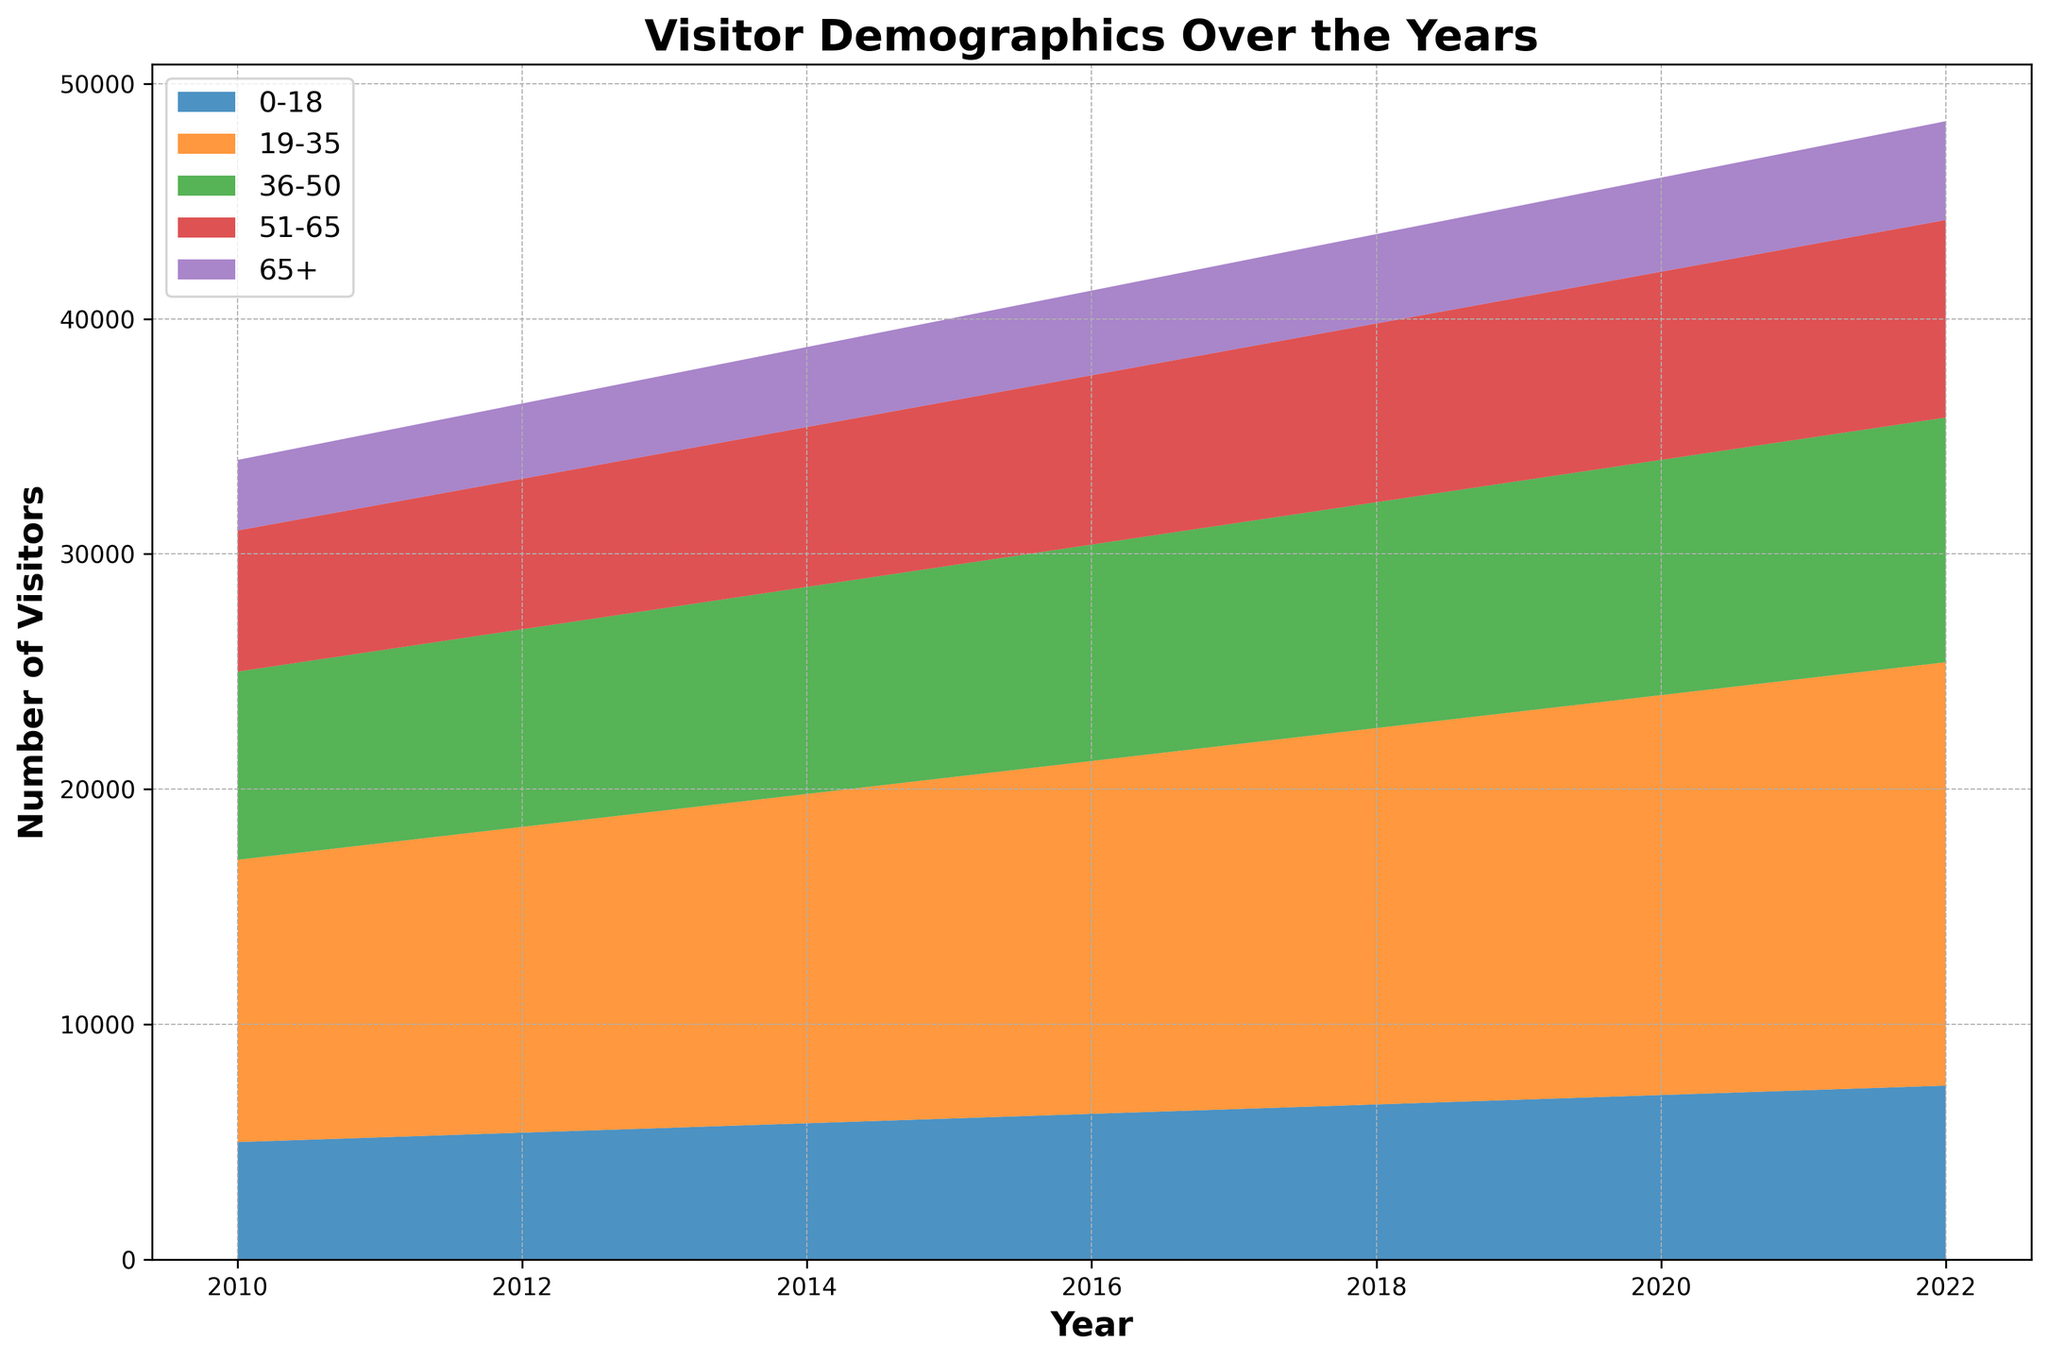What is the total number of visitors for the year 2015? Sum the numbers for each age group in 2015: 6000 (0-18) + 14500 (19-35) + 9000 (36-50) + 7000 (51-65) + 3500 (65+).
Answer: 40,000 Which age group showed the most significant growth in visitors from 2010 to 2022? Subtract the number of visitors in 2010 from the number in 2022 for each age group and find the maximum difference. (19-35) group: 18000 - 12000 = 6000; (0-18) group: 7400 - 5000 = 2400; (36-50) group: 10400 - 8000 = 2400; (51-65) group: 8400 - 6000 = 2400; (65+) group: 4200 - 3000 = 1200.
Answer: 19-35 group In which year did visitors aged 36-50 exceed 10,000 for the first time? Look at the 36-50 line and find the first year where the visitors in this age group exceed 10,000: that occurs in 2020.
Answer: 2020 Compare the increase in visitors for the age groups 0-18 and 65+ from 2010 to 2022. Which had a larger increase? Calculate the increase for each group: (0-18) group, 7400 - 5000 = 2400 increase; (65+) group, 4200 - 3000 = 1200 increase.
Answer: 0-18 group How many more visitors were there in the 19-35 age group compared to the 51-65 group in 2022? Subtract the number of visitors in 2022 for the 51-65 group from the 19-35 group: 18000 (19-35) - 8400 (51-65) = 9600.
Answer: 9600 Which year showed the least number of visitors for the 65+ age group? Identify the year with the smallest value in the 65+ line: the year 2010 with 3000 visitors.
Answer: 2010 What is the average number of visitors in the 36-50 age group from 2010 to 2022? Sum the 36-50 values from each year and divide by the number of years: (8000 + 8200 + 8400 + 8600 + 8800 + 9000 + 9200 + 9400 + 9600 + 9800 + 10000 + 10200 + 10400) / 13 = 9262.
Answer: 9262 Which age group consistently had the highest number of visitors each year from 2010 to 2022? Look at each year and determine which age group has the highest value; the 19-35 age group always has the highest number of visitors.
Answer: 19-35 group 